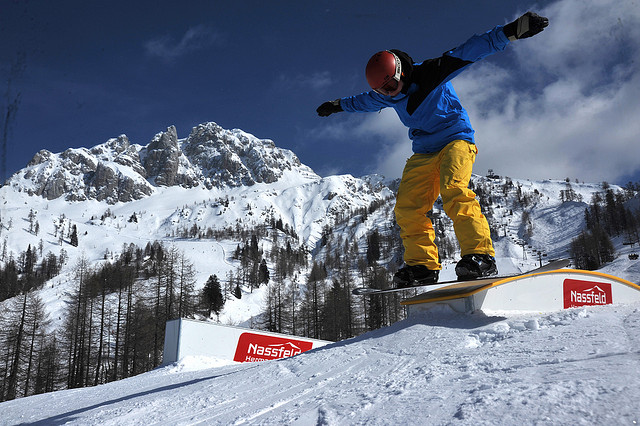Can you imagine a fictional story about this snowboarding scene? In a world where the mountains sing ancient songs and snowflakes glisten like diamonds under an eternal sun, there exists a legendary contest held only once every century. This snowboarder, known simply as the 'Sky Dancer', has come to challenge the sacred rail of the Elder Peaks. Each graceful move he makes is said to summon the spirits of the mountains, and with every trick, he etches his name into the tapestry of time. The Sky Dancer, with his blue jacket as a cloak of the azure sky and yellow pants like rays of the sun, defies gravity to prove his worth to the mountain spirits, hoping to earn their blessing. 